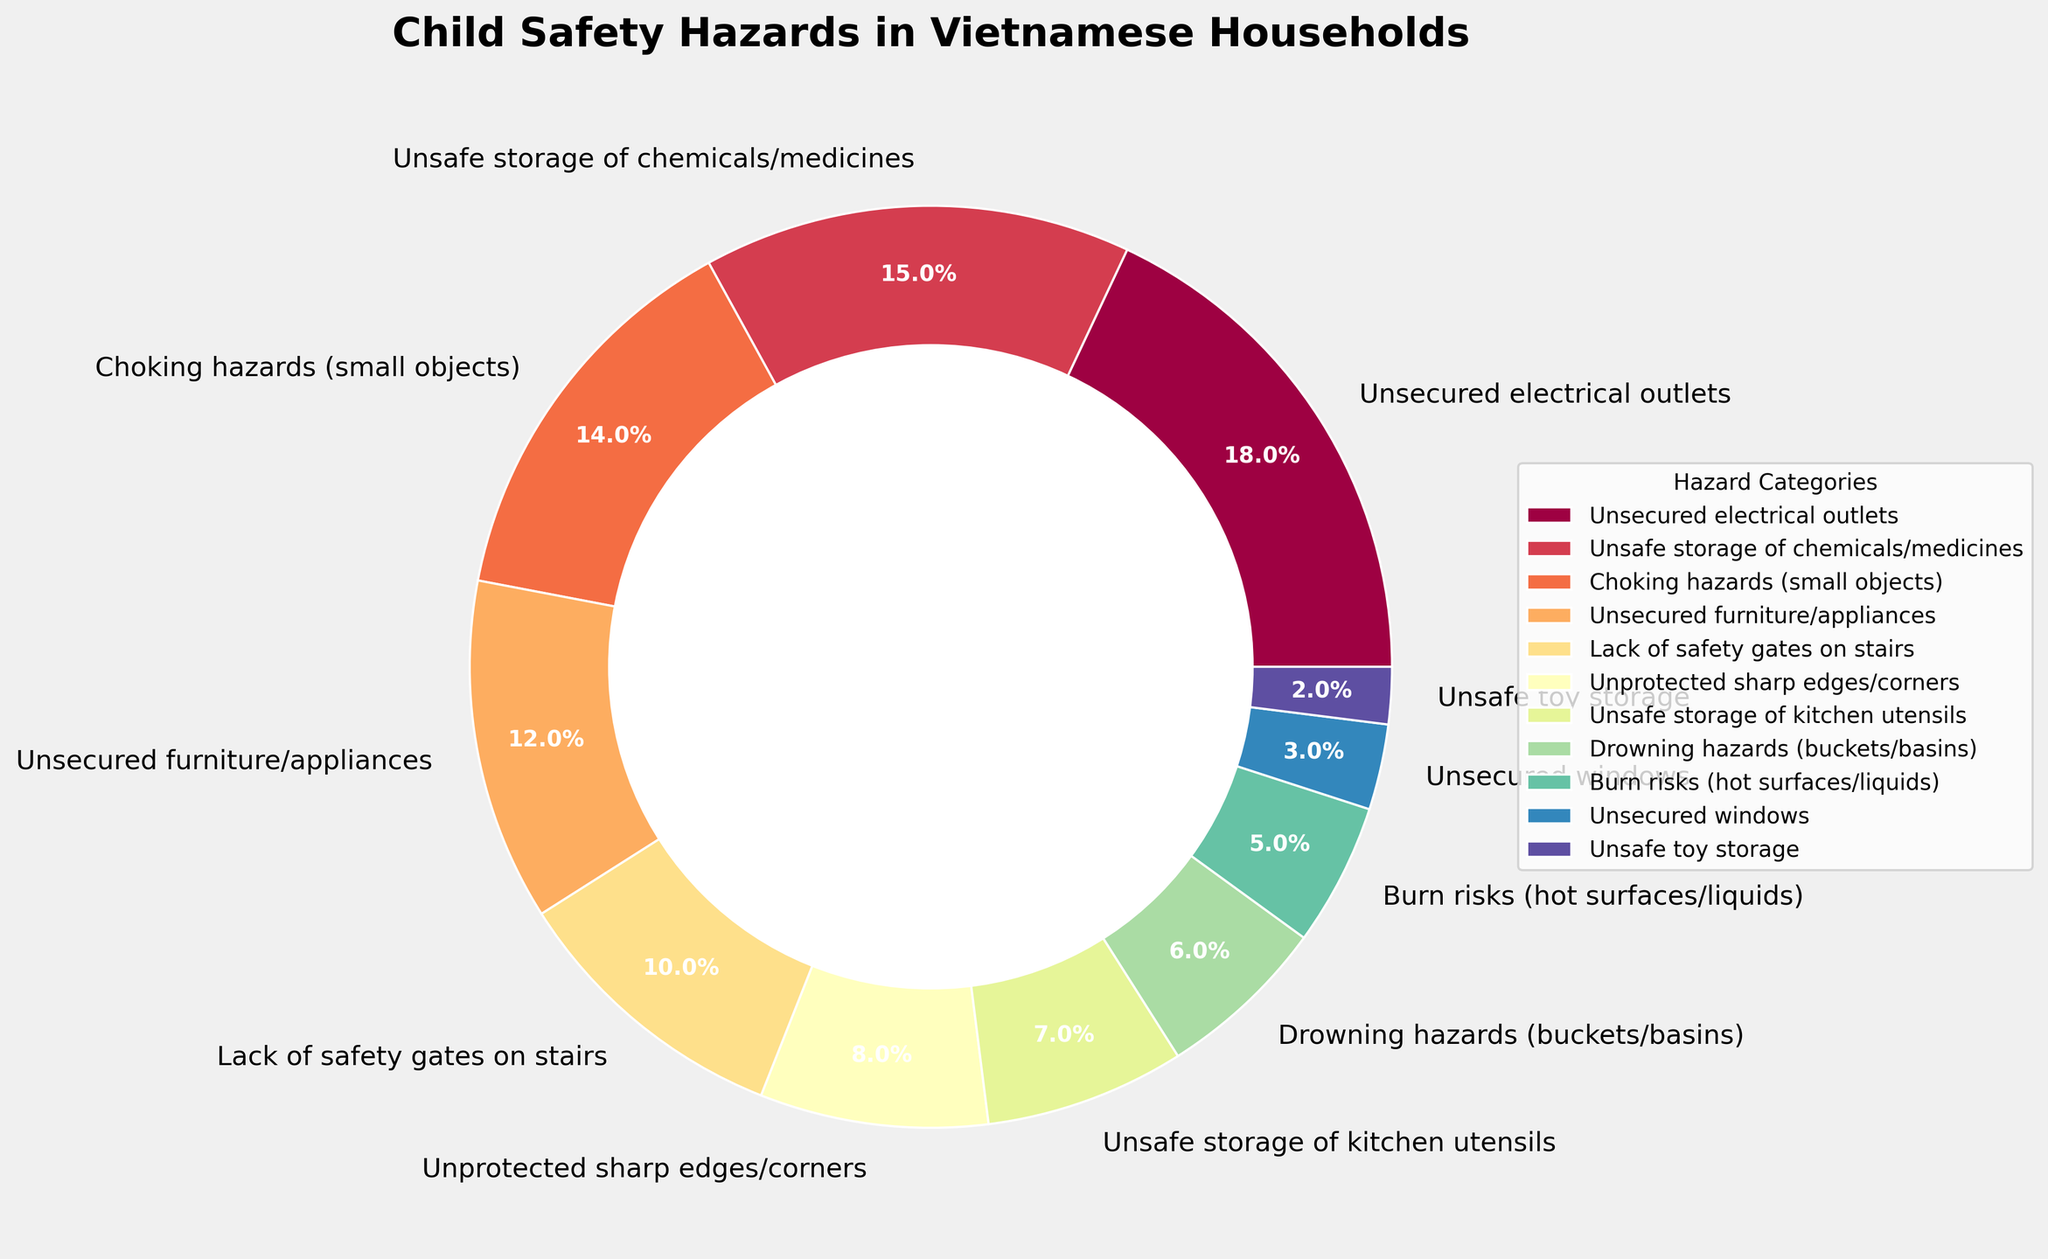What is the most significant child safety hazard in Vietnamese households? The pie chart shows that 'Unsecured electrical outlets' have the highest percentage among the hazards listed, with 18%.
Answer: Unsecured electrical outlets Which three hazards have the closest percentages to each other? By observing the pie chart, 'Lack of safety gates on stairs' (10%), 'Unprotected sharp edges/corners' (8%), and 'Unsafe storage of kitchen utensils' (7%) have the closest percentages.
Answer: Lack of safety gates on stairs, Unprotected sharp edges/corners, and Unsafe storage of kitchen utensils What is the combined percentage of hazards related to furniture and kitchen items? The relevant categories are 'Unsecured furniture/appliances' (12%) and 'Unsafe storage of kitchen utensils' (7%). Summing these gives 12% + 7% = 19%.
Answer: 19% Which hazards together constitute over one-third of the total hazards? 'Unsecured electrical outlets' (18%) and 'Unsafe storage of chemicals/medicines' (15%) together sum to 18% + 15% = 33%, which is very close, but 'Choking hazards (small objects)' (14%) added increases it beyond one-third: 18% + 15% + 14% = 47%.
Answer: Unsecured electrical outlets, Unsafe storage of chemicals/medicines, and Choking hazards (small objects) How do drowning hazards compare to burn risks? 'Drowning hazards (buckets/basins)' have a percentage of 6%, while 'Burn risks (hot surfaces/liquids)' have 5%. By comparing these, drowning hazards have a slightly higher percentage.
Answer: Drowning hazards are higher What is the percentage difference between the highest and lowest hazards? 'Unsecured electrical outlets' is the highest at 18%, and 'Unsafe toy storage' is the lowest at 2%. The percentage difference is 18% - 2% = 16%.
Answer: 16% How does the percentage of 'Unsecured windows' compare to that of 'Unsafe toy storage'? From the pie chart, 'Unsecured windows' have a percentage of 3%, while 'Unsafe toy storage' is at 2%. Therefore, 'Unsecured windows' have a higher percentage compared to 'Unsafe toy storage'.
Answer: Unsecured windows are higher Which category would you target first to significantly reduce more than a quarter of the hazards? To reduce more than a quarter (25%), targeting 'Unsecured electrical outlets' (18%) and 'Unsafe storage of chemicals/medicines' (15%) would be significant. Together, these sum to 18% + 15% = 33%, which is more than a quarter.
Answer: Unsecured electrical outlets and Unsafe storage of chemicals/medicines If 'Unsecured windows' represented twice their current percentage, what would their new percentage be and how would it compare with 'Choking hazards'? The current percentage for 'Unsecured windows' is 3%. If doubled, it would be 3% * 2 = 6%, which would then be equal to 'Drowning hazards' (6%) but still less than 'Choking hazards' (14%).
Answer: 6%, still less than Choking hazards What is the total percentage of all safety hazards related to handling substances (electricity, chemicals, burn risks)? Summing the percentages of 'Unsecured electrical outlets' (18%), 'Unsafe storage of chemicals/medicines' (15%), and 'Burn risks (hot surfaces/liquids)' (5%) gives 18% + 15% + 5% = 38%.
Answer: 38% 